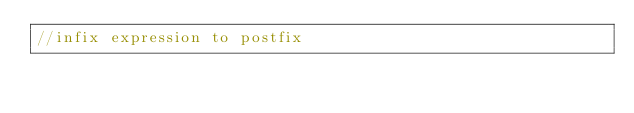<code> <loc_0><loc_0><loc_500><loc_500><_C_>//infix expression to postfix
</code> 